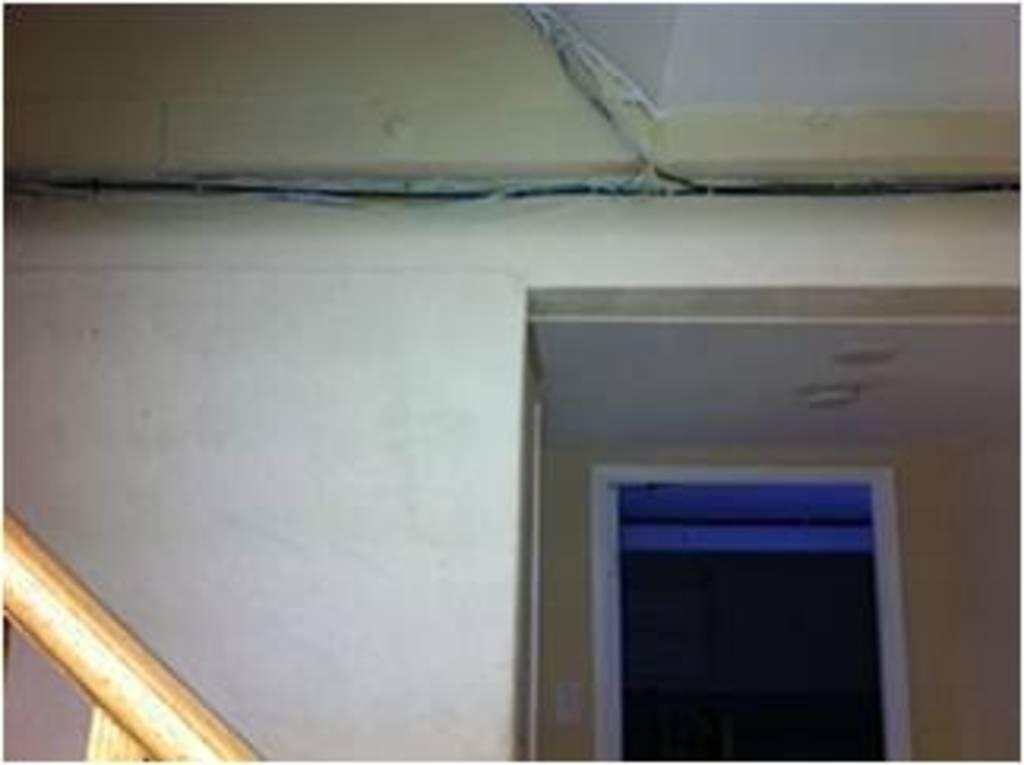What type of space is depicted in the image? The image shows an inner view of a building's room. What can be seen inside the room? There is a wooden pole in the room. Are there any openings or entrances in the room? Yes, there is a door in the room. What part of the building's structure is visible in the image? The roof is visible in the image. What color is the wall in the room? The wall is in white color. How many cows can be seen grazing on the grass in the image? There are no cows or grass present in the image; it shows an inner view of a building's room. What type of birds are flying near the wooden pole in the image? There are no birds visible in the image; it only shows a wooden pole, a door, the roof, and a white wall. 